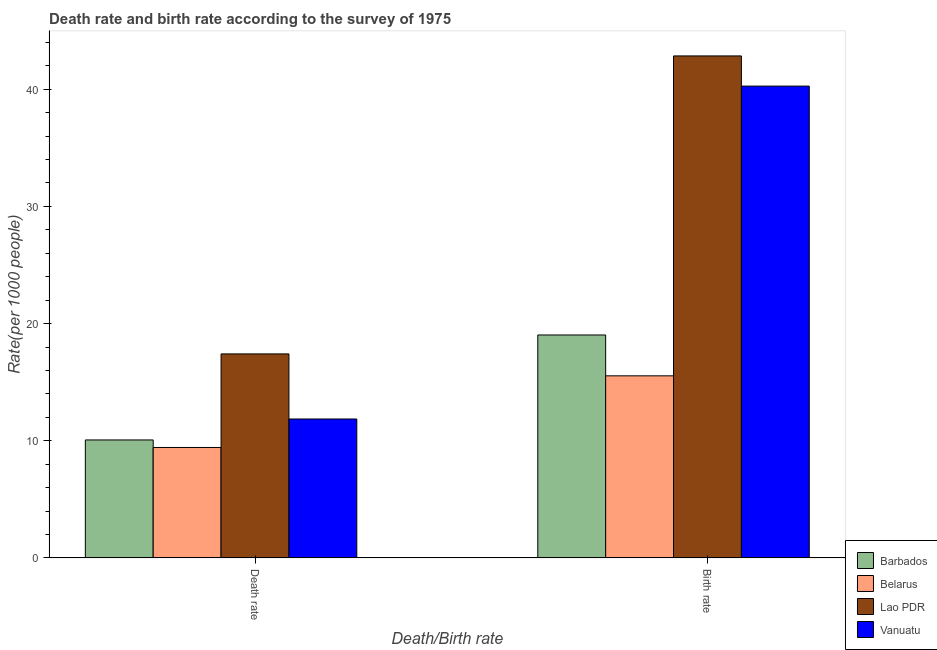How many different coloured bars are there?
Your answer should be very brief. 4. How many bars are there on the 1st tick from the left?
Keep it short and to the point. 4. What is the label of the 1st group of bars from the left?
Keep it short and to the point. Death rate. What is the birth rate in Lao PDR?
Offer a very short reply. 42.84. Across all countries, what is the maximum death rate?
Give a very brief answer. 17.41. Across all countries, what is the minimum birth rate?
Your response must be concise. 15.54. In which country was the birth rate maximum?
Offer a very short reply. Lao PDR. In which country was the death rate minimum?
Provide a short and direct response. Belarus. What is the total death rate in the graph?
Keep it short and to the point. 48.76. What is the difference between the death rate in Vanuatu and that in Belarus?
Offer a very short reply. 2.43. What is the difference between the death rate in Barbados and the birth rate in Vanuatu?
Offer a very short reply. -30.2. What is the average birth rate per country?
Your answer should be compact. 29.42. What is the difference between the birth rate and death rate in Vanuatu?
Provide a short and direct response. 28.41. What is the ratio of the birth rate in Lao PDR to that in Belarus?
Ensure brevity in your answer.  2.76. Is the death rate in Lao PDR less than that in Barbados?
Your answer should be compact. No. What does the 1st bar from the left in Death rate represents?
Offer a very short reply. Barbados. What does the 2nd bar from the right in Death rate represents?
Offer a very short reply. Lao PDR. Does the graph contain grids?
Keep it short and to the point. No. Where does the legend appear in the graph?
Offer a terse response. Bottom right. How are the legend labels stacked?
Ensure brevity in your answer.  Vertical. What is the title of the graph?
Offer a very short reply. Death rate and birth rate according to the survey of 1975. Does "Madagascar" appear as one of the legend labels in the graph?
Make the answer very short. No. What is the label or title of the X-axis?
Your answer should be compact. Death/Birth rate. What is the label or title of the Y-axis?
Your response must be concise. Rate(per 1000 people). What is the Rate(per 1000 people) in Barbados in Death rate?
Provide a succinct answer. 10.07. What is the Rate(per 1000 people) of Belarus in Death rate?
Your answer should be very brief. 9.43. What is the Rate(per 1000 people) in Lao PDR in Death rate?
Provide a succinct answer. 17.41. What is the Rate(per 1000 people) of Vanuatu in Death rate?
Your answer should be compact. 11.86. What is the Rate(per 1000 people) of Barbados in Birth rate?
Make the answer very short. 19.03. What is the Rate(per 1000 people) of Belarus in Birth rate?
Keep it short and to the point. 15.54. What is the Rate(per 1000 people) of Lao PDR in Birth rate?
Offer a terse response. 42.84. What is the Rate(per 1000 people) in Vanuatu in Birth rate?
Your answer should be very brief. 40.27. Across all Death/Birth rate, what is the maximum Rate(per 1000 people) in Barbados?
Give a very brief answer. 19.03. Across all Death/Birth rate, what is the maximum Rate(per 1000 people) of Belarus?
Keep it short and to the point. 15.54. Across all Death/Birth rate, what is the maximum Rate(per 1000 people) in Lao PDR?
Your response must be concise. 42.84. Across all Death/Birth rate, what is the maximum Rate(per 1000 people) of Vanuatu?
Make the answer very short. 40.27. Across all Death/Birth rate, what is the minimum Rate(per 1000 people) of Barbados?
Provide a short and direct response. 10.07. Across all Death/Birth rate, what is the minimum Rate(per 1000 people) of Belarus?
Keep it short and to the point. 9.43. Across all Death/Birth rate, what is the minimum Rate(per 1000 people) in Lao PDR?
Provide a short and direct response. 17.41. Across all Death/Birth rate, what is the minimum Rate(per 1000 people) of Vanuatu?
Your answer should be compact. 11.86. What is the total Rate(per 1000 people) in Barbados in the graph?
Your response must be concise. 29.09. What is the total Rate(per 1000 people) of Belarus in the graph?
Your response must be concise. 24.96. What is the total Rate(per 1000 people) in Lao PDR in the graph?
Keep it short and to the point. 60.26. What is the total Rate(per 1000 people) in Vanuatu in the graph?
Your answer should be very brief. 52.12. What is the difference between the Rate(per 1000 people) of Barbados in Death rate and that in Birth rate?
Give a very brief answer. -8.96. What is the difference between the Rate(per 1000 people) of Belarus in Death rate and that in Birth rate?
Give a very brief answer. -6.12. What is the difference between the Rate(per 1000 people) of Lao PDR in Death rate and that in Birth rate?
Your answer should be compact. -25.43. What is the difference between the Rate(per 1000 people) of Vanuatu in Death rate and that in Birth rate?
Provide a succinct answer. -28.41. What is the difference between the Rate(per 1000 people) of Barbados in Death rate and the Rate(per 1000 people) of Belarus in Birth rate?
Provide a short and direct response. -5.47. What is the difference between the Rate(per 1000 people) in Barbados in Death rate and the Rate(per 1000 people) in Lao PDR in Birth rate?
Offer a terse response. -32.78. What is the difference between the Rate(per 1000 people) of Barbados in Death rate and the Rate(per 1000 people) of Vanuatu in Birth rate?
Your answer should be very brief. -30.2. What is the difference between the Rate(per 1000 people) of Belarus in Death rate and the Rate(per 1000 people) of Lao PDR in Birth rate?
Provide a short and direct response. -33.42. What is the difference between the Rate(per 1000 people) of Belarus in Death rate and the Rate(per 1000 people) of Vanuatu in Birth rate?
Provide a succinct answer. -30.84. What is the difference between the Rate(per 1000 people) in Lao PDR in Death rate and the Rate(per 1000 people) in Vanuatu in Birth rate?
Give a very brief answer. -22.86. What is the average Rate(per 1000 people) in Barbados per Death/Birth rate?
Give a very brief answer. 14.55. What is the average Rate(per 1000 people) in Belarus per Death/Birth rate?
Offer a terse response. 12.48. What is the average Rate(per 1000 people) in Lao PDR per Death/Birth rate?
Give a very brief answer. 30.13. What is the average Rate(per 1000 people) of Vanuatu per Death/Birth rate?
Offer a very short reply. 26.06. What is the difference between the Rate(per 1000 people) in Barbados and Rate(per 1000 people) in Belarus in Death rate?
Offer a terse response. 0.64. What is the difference between the Rate(per 1000 people) in Barbados and Rate(per 1000 people) in Lao PDR in Death rate?
Give a very brief answer. -7.34. What is the difference between the Rate(per 1000 people) in Barbados and Rate(per 1000 people) in Vanuatu in Death rate?
Make the answer very short. -1.79. What is the difference between the Rate(per 1000 people) of Belarus and Rate(per 1000 people) of Lao PDR in Death rate?
Provide a succinct answer. -7.99. What is the difference between the Rate(per 1000 people) of Belarus and Rate(per 1000 people) of Vanuatu in Death rate?
Make the answer very short. -2.43. What is the difference between the Rate(per 1000 people) of Lao PDR and Rate(per 1000 people) of Vanuatu in Death rate?
Give a very brief answer. 5.55. What is the difference between the Rate(per 1000 people) in Barbados and Rate(per 1000 people) in Belarus in Birth rate?
Your response must be concise. 3.49. What is the difference between the Rate(per 1000 people) of Barbados and Rate(per 1000 people) of Lao PDR in Birth rate?
Make the answer very short. -23.82. What is the difference between the Rate(per 1000 people) of Barbados and Rate(per 1000 people) of Vanuatu in Birth rate?
Your response must be concise. -21.24. What is the difference between the Rate(per 1000 people) of Belarus and Rate(per 1000 people) of Lao PDR in Birth rate?
Ensure brevity in your answer.  -27.3. What is the difference between the Rate(per 1000 people) of Belarus and Rate(per 1000 people) of Vanuatu in Birth rate?
Offer a very short reply. -24.73. What is the difference between the Rate(per 1000 people) in Lao PDR and Rate(per 1000 people) in Vanuatu in Birth rate?
Offer a terse response. 2.58. What is the ratio of the Rate(per 1000 people) of Barbados in Death rate to that in Birth rate?
Offer a terse response. 0.53. What is the ratio of the Rate(per 1000 people) in Belarus in Death rate to that in Birth rate?
Make the answer very short. 0.61. What is the ratio of the Rate(per 1000 people) in Lao PDR in Death rate to that in Birth rate?
Give a very brief answer. 0.41. What is the ratio of the Rate(per 1000 people) in Vanuatu in Death rate to that in Birth rate?
Make the answer very short. 0.29. What is the difference between the highest and the second highest Rate(per 1000 people) in Barbados?
Give a very brief answer. 8.96. What is the difference between the highest and the second highest Rate(per 1000 people) in Belarus?
Ensure brevity in your answer.  6.12. What is the difference between the highest and the second highest Rate(per 1000 people) of Lao PDR?
Ensure brevity in your answer.  25.43. What is the difference between the highest and the second highest Rate(per 1000 people) in Vanuatu?
Provide a succinct answer. 28.41. What is the difference between the highest and the lowest Rate(per 1000 people) in Barbados?
Your answer should be compact. 8.96. What is the difference between the highest and the lowest Rate(per 1000 people) in Belarus?
Your answer should be very brief. 6.12. What is the difference between the highest and the lowest Rate(per 1000 people) in Lao PDR?
Your answer should be compact. 25.43. What is the difference between the highest and the lowest Rate(per 1000 people) in Vanuatu?
Give a very brief answer. 28.41. 